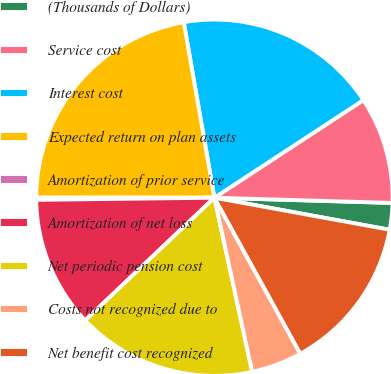Convert chart. <chart><loc_0><loc_0><loc_500><loc_500><pie_chart><fcel>(Thousands of Dollars)<fcel>Service cost<fcel>Interest cost<fcel>Expected return on plan assets<fcel>Amortization of prior service<fcel>Amortization of net loss<fcel>Net periodic pension cost<fcel>Costs not recognized due to<fcel>Net benefit cost recognized<nl><fcel>2.41%<fcel>9.7%<fcel>18.52%<fcel>22.24%<fcel>0.2%<fcel>11.9%<fcel>16.31%<fcel>4.61%<fcel>14.11%<nl></chart> 